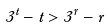Convert formula to latex. <formula><loc_0><loc_0><loc_500><loc_500>3 ^ { t } - t > 3 ^ { r } - r</formula> 